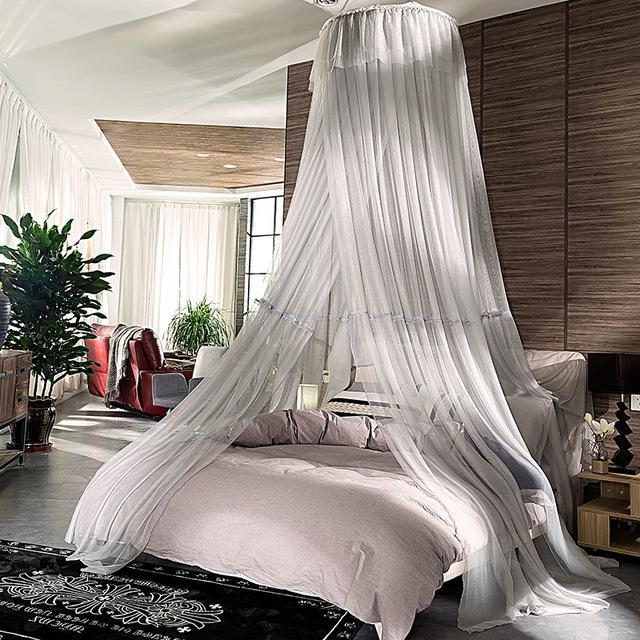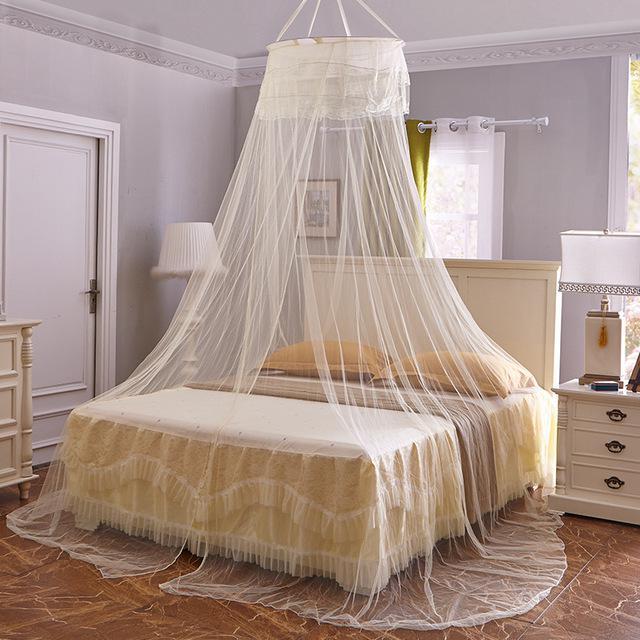The first image is the image on the left, the second image is the image on the right. Considering the images on both sides, is "Each image shows a gauzy canopy that drapes from a round shape suspended from the ceiling, but the left image features a white canopy while the right image features an off-white canopy." valid? Answer yes or no. Yes. 